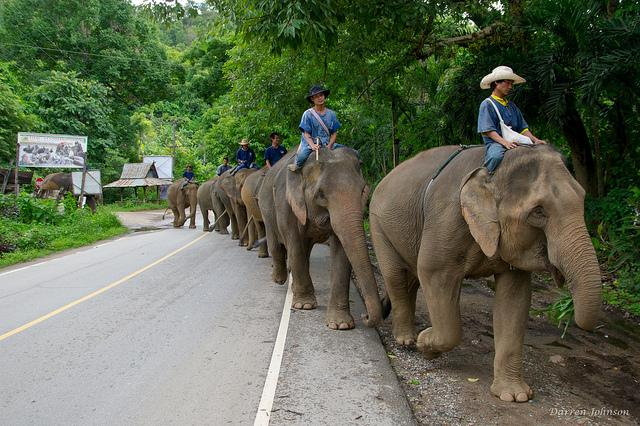What is on top of the elephants? Please explain your reasoning. people. There is a line of elephants with people riding on top of each one. 